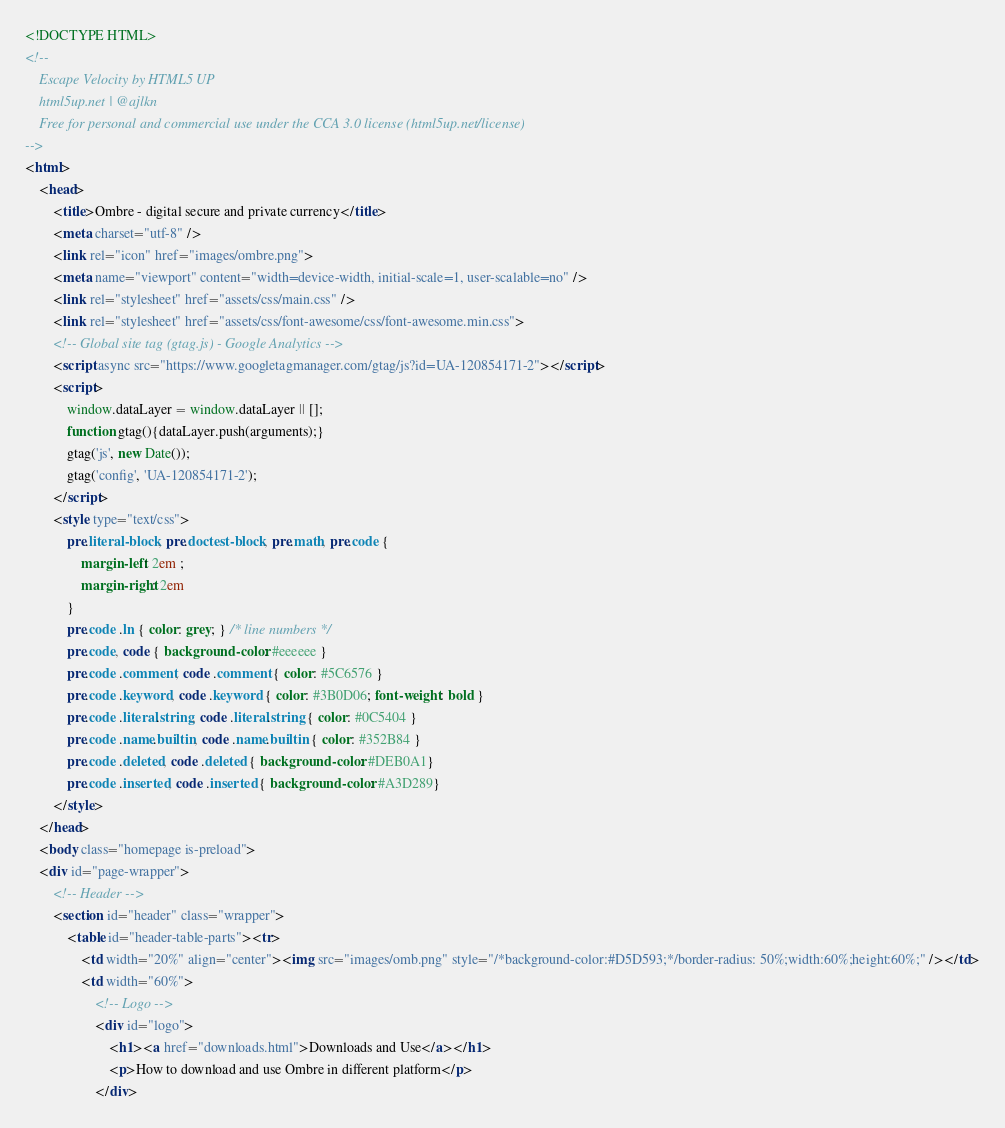Convert code to text. <code><loc_0><loc_0><loc_500><loc_500><_HTML_><!DOCTYPE HTML>
<!--
	Escape Velocity by HTML5 UP
	html5up.net | @ajlkn
	Free for personal and commercial use under the CCA 3.0 license (html5up.net/license)
-->
<html>
	<head>
		<title>Ombre - digital secure and private currency</title>
		<meta charset="utf-8" />
		<link rel="icon" href="images/ombre.png">
		<meta name="viewport" content="width=device-width, initial-scale=1, user-scalable=no" />
		<link rel="stylesheet" href="assets/css/main.css" />
		<link rel="stylesheet" href="assets/css/font-awesome/css/font-awesome.min.css">
		<!-- Global site tag (gtag.js) - Google Analytics -->
		<script async src="https://www.googletagmanager.com/gtag/js?id=UA-120854171-2"></script>
		<script>
			window.dataLayer = window.dataLayer || [];
			function gtag(){dataLayer.push(arguments);}
			gtag('js', new Date());
			gtag('config', 'UA-120854171-2');
		</script>
		<style type="text/css">
			pre.literal-block, pre.doctest-block, pre.math, pre.code {
				margin-left: 2em ;
				margin-right: 2em
			}
			pre.code .ln { color: grey; } /* line numbers */
			pre.code, code { background-color: #eeeeee }
			pre.code .comment, code .comment { color: #5C6576 }
			pre.code .keyword, code .keyword { color: #3B0D06; font-weight: bold }
			pre.code .literal.string, code .literal.string { color: #0C5404 }
			pre.code .name.builtin, code .name.builtin { color: #352B84 }
			pre.code .deleted, code .deleted { background-color: #DEB0A1}
			pre.code .inserted, code .inserted { background-color: #A3D289}
		</style>
	</head>
	<body class="homepage is-preload">
	<div id="page-wrapper">
		<!-- Header -->
		<section id="header" class="wrapper">
			<table id="header-table-parts"><tr>
				<td width="20%" align="center"><img src="images/omb.png" style="/*background-color:#D5D593;*/border-radius: 50%;width:60%;height:60%;" /></td>
				<td width="60%">
					<!-- Logo -->
					<div id="logo">
						<h1><a href="downloads.html">Downloads and Use</a></h1>
						<p>How to download and use Ombre in different platform</p>
					</div></code> 